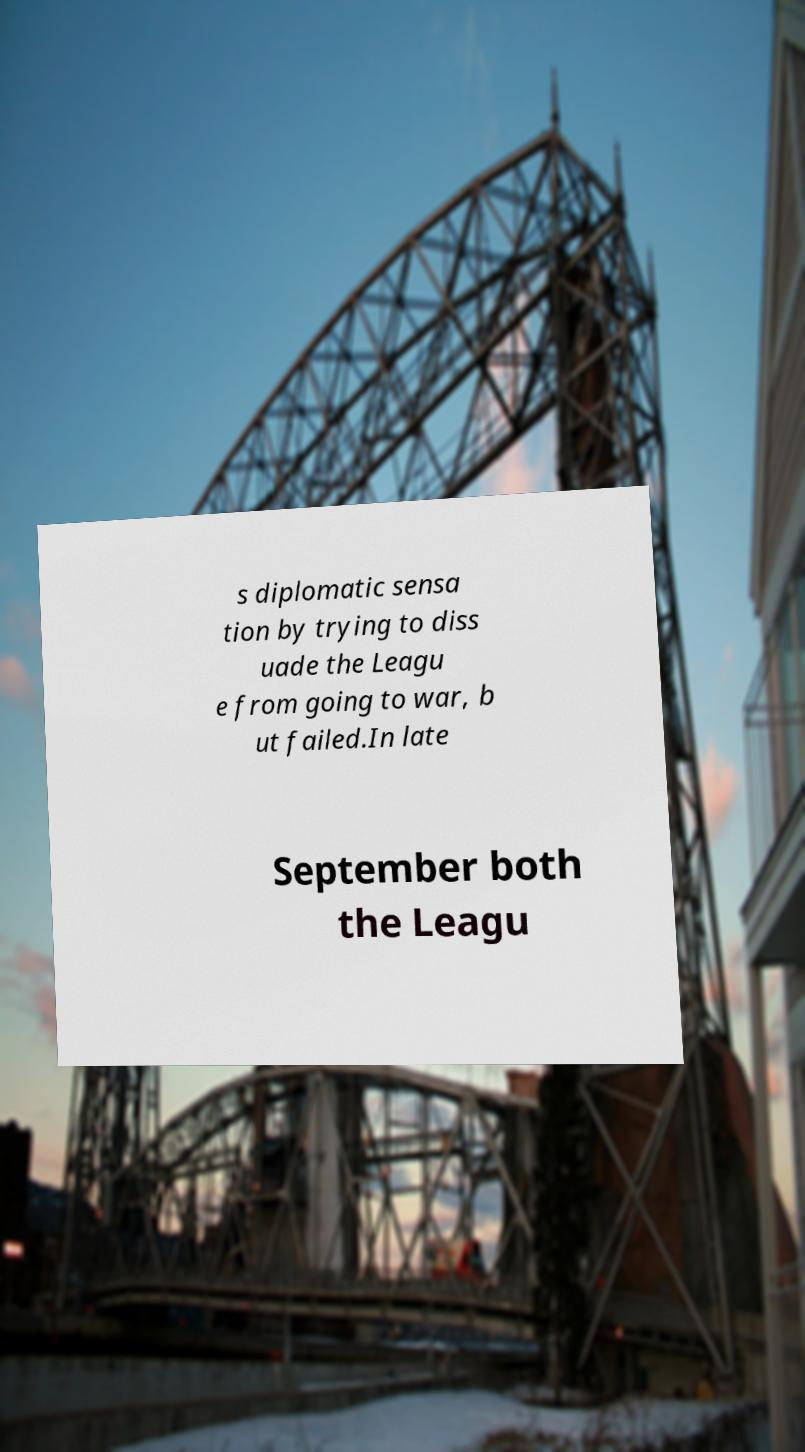There's text embedded in this image that I need extracted. Can you transcribe it verbatim? s diplomatic sensa tion by trying to diss uade the Leagu e from going to war, b ut failed.In late September both the Leagu 